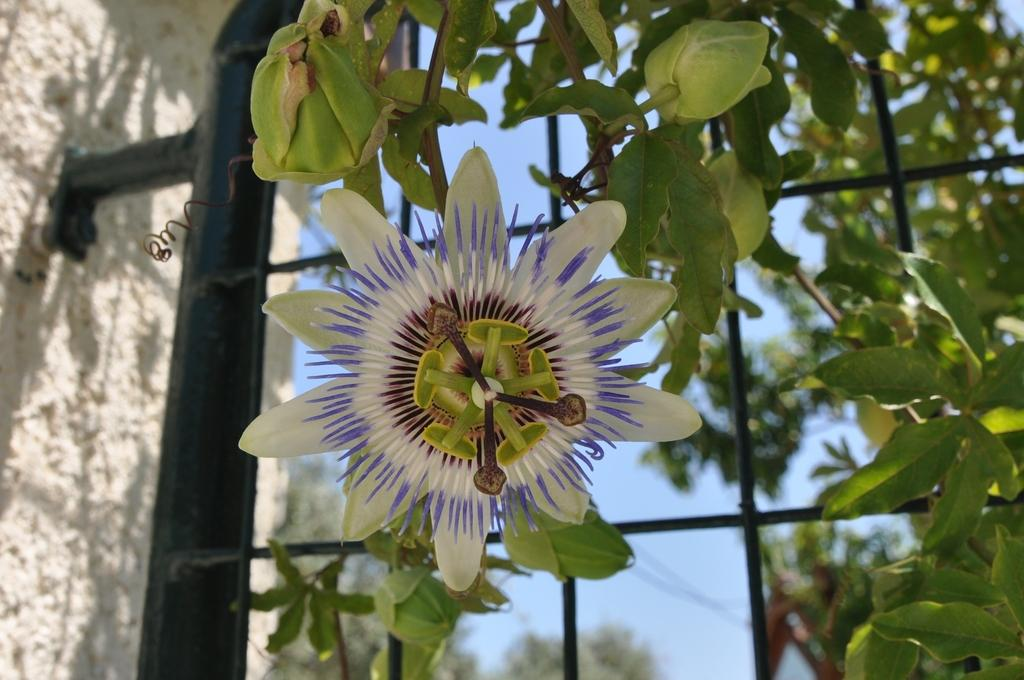What type of plant is visible in the image? There is a flower in the image. What else can be seen on the plant besides the flower? There are leaves in the image. What structure is present in the image that might be used for ventilation or security? There is a grille in the image. What type of background can be seen in the image? The sky is visible in the background of the image. What type of surface or barrier is present in the image? There is a wall in the image. What type of bone can be seen in the image? There is no bone present in the image. 